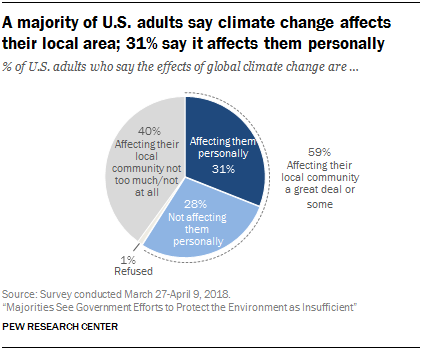Draw attention to some important aspects in this diagram. The value of the dark blue segment is 31. The sum of the values of the dark blue and light blue segments is not equal to the sum of the values of the white and grey segments. 